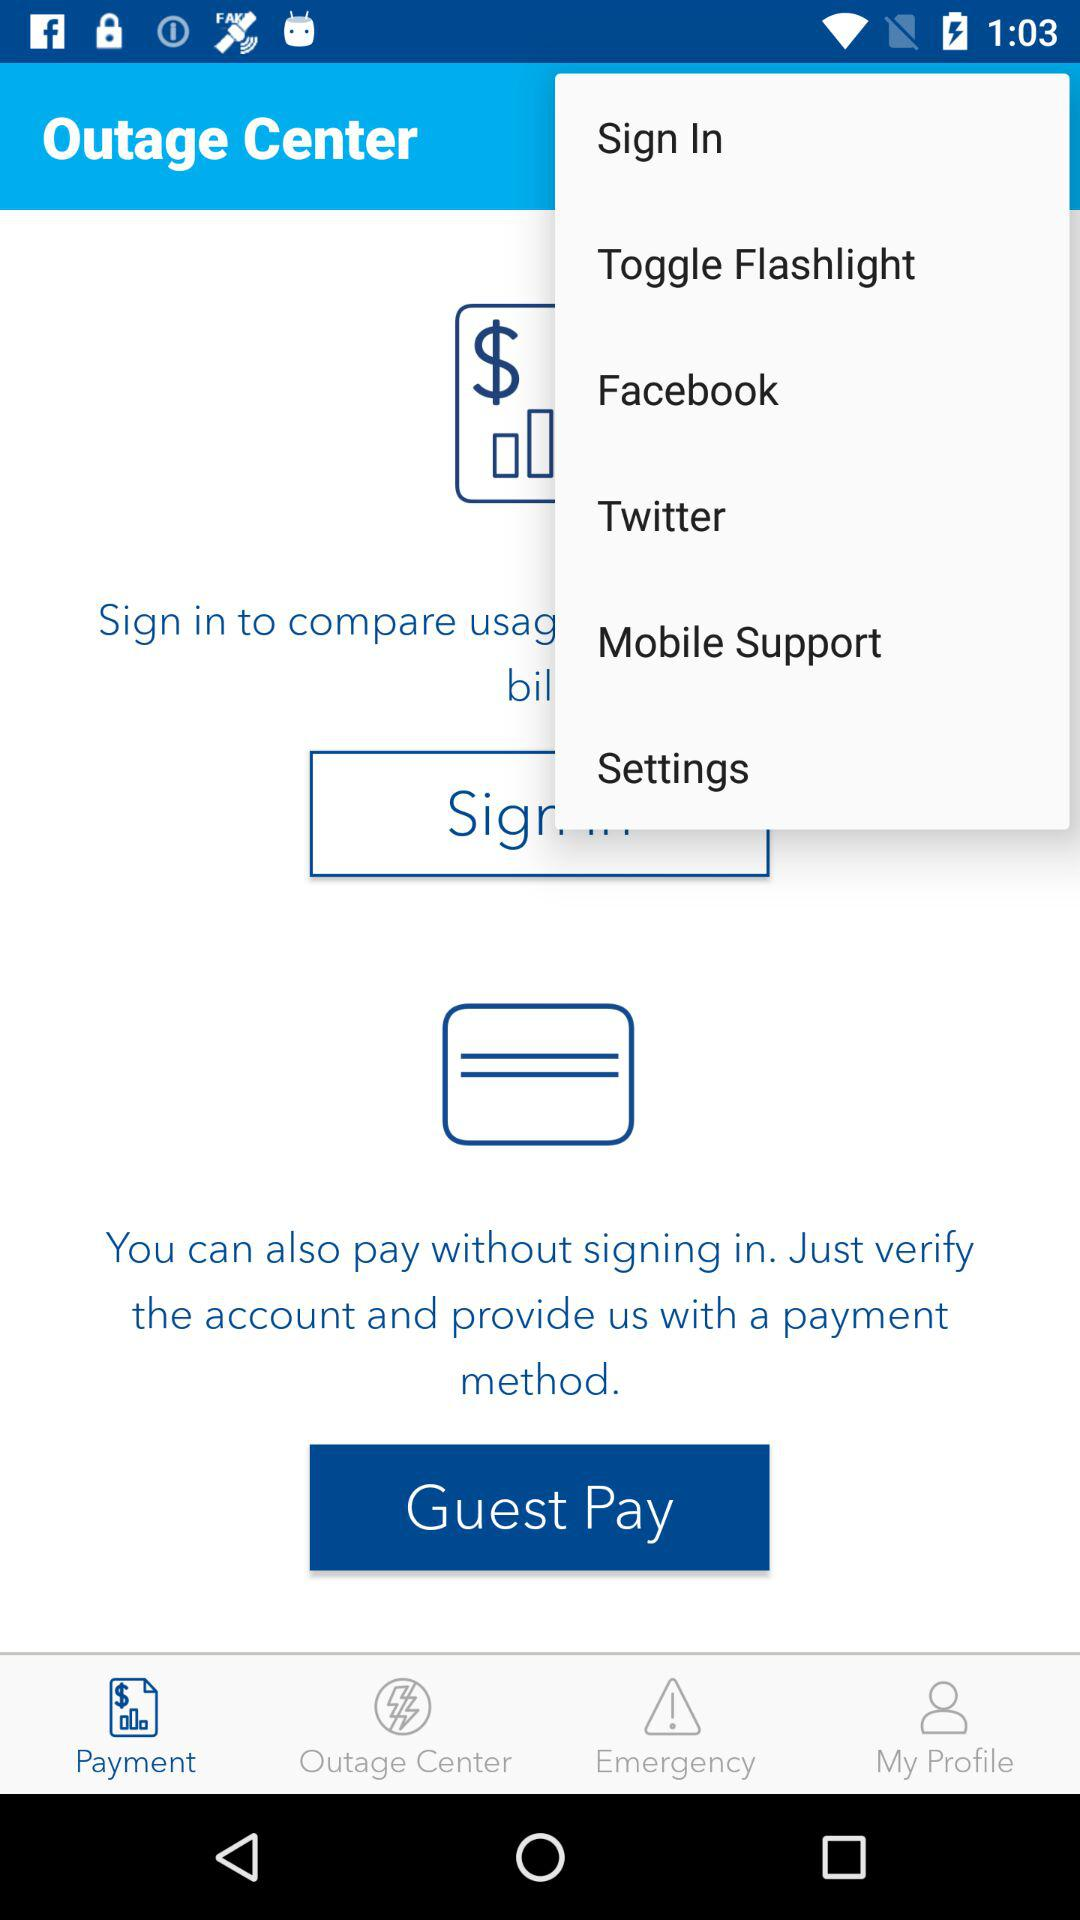What is the name of the application? The name of the application is "Outage Center". 